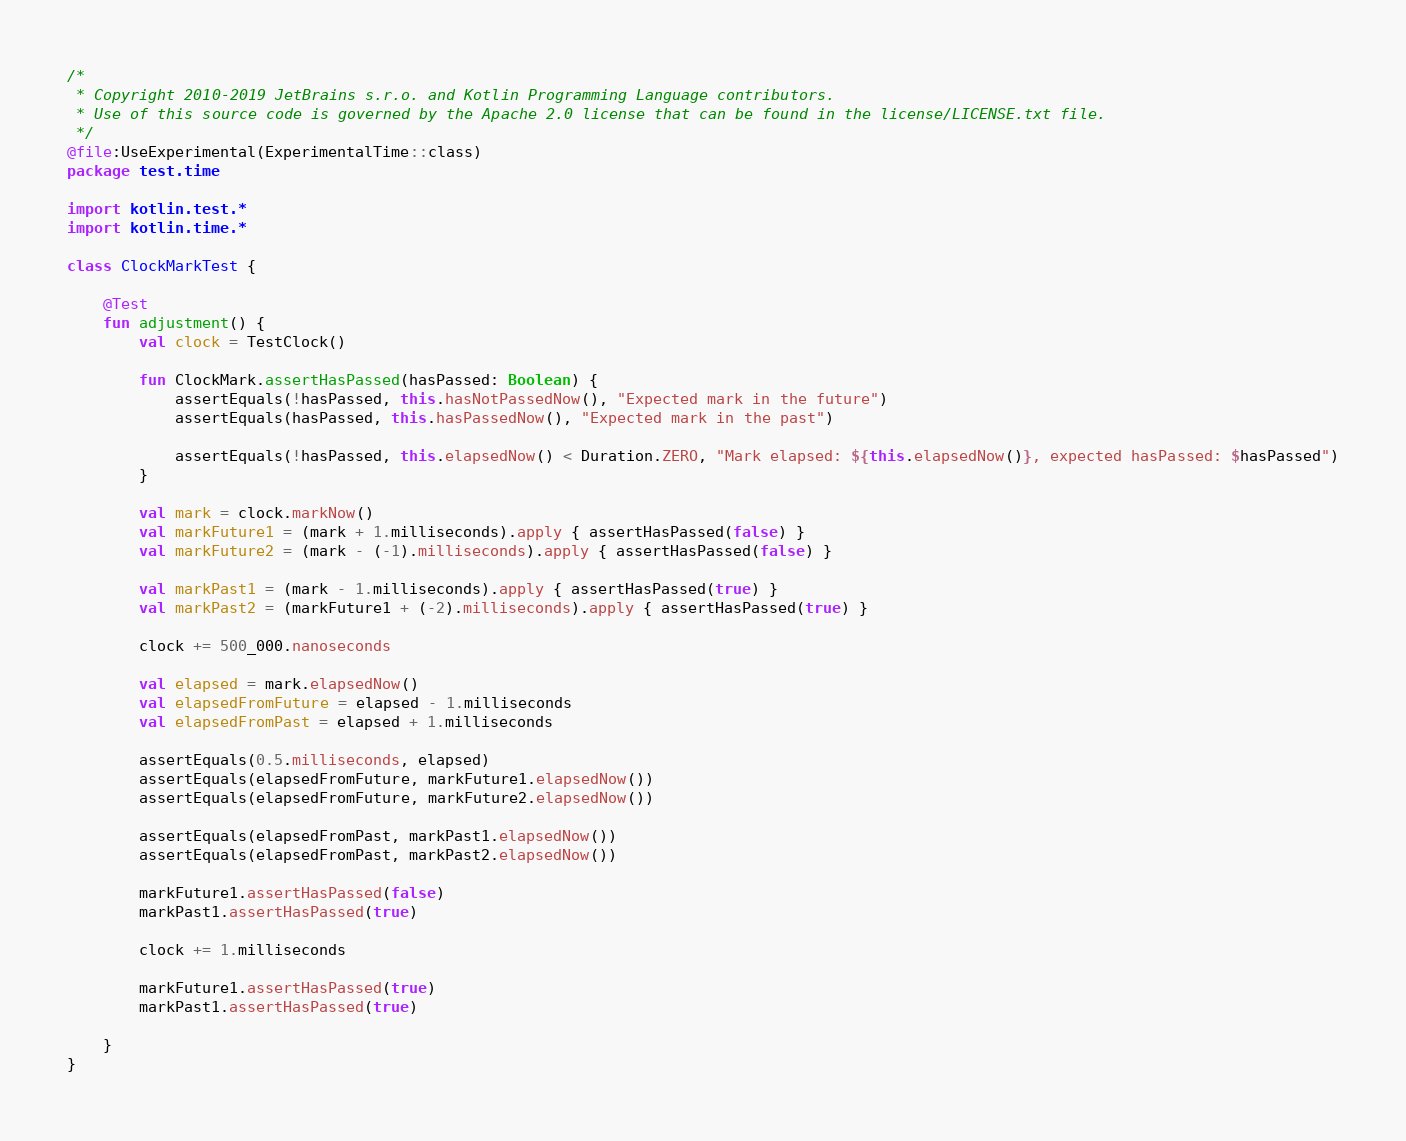<code> <loc_0><loc_0><loc_500><loc_500><_Kotlin_>/*
 * Copyright 2010-2019 JetBrains s.r.o. and Kotlin Programming Language contributors.
 * Use of this source code is governed by the Apache 2.0 license that can be found in the license/LICENSE.txt file.
 */
@file:UseExperimental(ExperimentalTime::class)
package test.time

import kotlin.test.*
import kotlin.time.*

class ClockMarkTest {

    @Test
    fun adjustment() {
        val clock = TestClock()

        fun ClockMark.assertHasPassed(hasPassed: Boolean) {
            assertEquals(!hasPassed, this.hasNotPassedNow(), "Expected mark in the future")
            assertEquals(hasPassed, this.hasPassedNow(), "Expected mark in the past")

            assertEquals(!hasPassed, this.elapsedNow() < Duration.ZERO, "Mark elapsed: ${this.elapsedNow()}, expected hasPassed: $hasPassed")
        }

        val mark = clock.markNow()
        val markFuture1 = (mark + 1.milliseconds).apply { assertHasPassed(false) }
        val markFuture2 = (mark - (-1).milliseconds).apply { assertHasPassed(false) }

        val markPast1 = (mark - 1.milliseconds).apply { assertHasPassed(true) }
        val markPast2 = (markFuture1 + (-2).milliseconds).apply { assertHasPassed(true) }

        clock += 500_000.nanoseconds

        val elapsed = mark.elapsedNow()
        val elapsedFromFuture = elapsed - 1.milliseconds
        val elapsedFromPast = elapsed + 1.milliseconds

        assertEquals(0.5.milliseconds, elapsed)
        assertEquals(elapsedFromFuture, markFuture1.elapsedNow())
        assertEquals(elapsedFromFuture, markFuture2.elapsedNow())

        assertEquals(elapsedFromPast, markPast1.elapsedNow())
        assertEquals(elapsedFromPast, markPast2.elapsedNow())

        markFuture1.assertHasPassed(false)
        markPast1.assertHasPassed(true)

        clock += 1.milliseconds

        markFuture1.assertHasPassed(true)
        markPast1.assertHasPassed(true)

    }
}</code> 